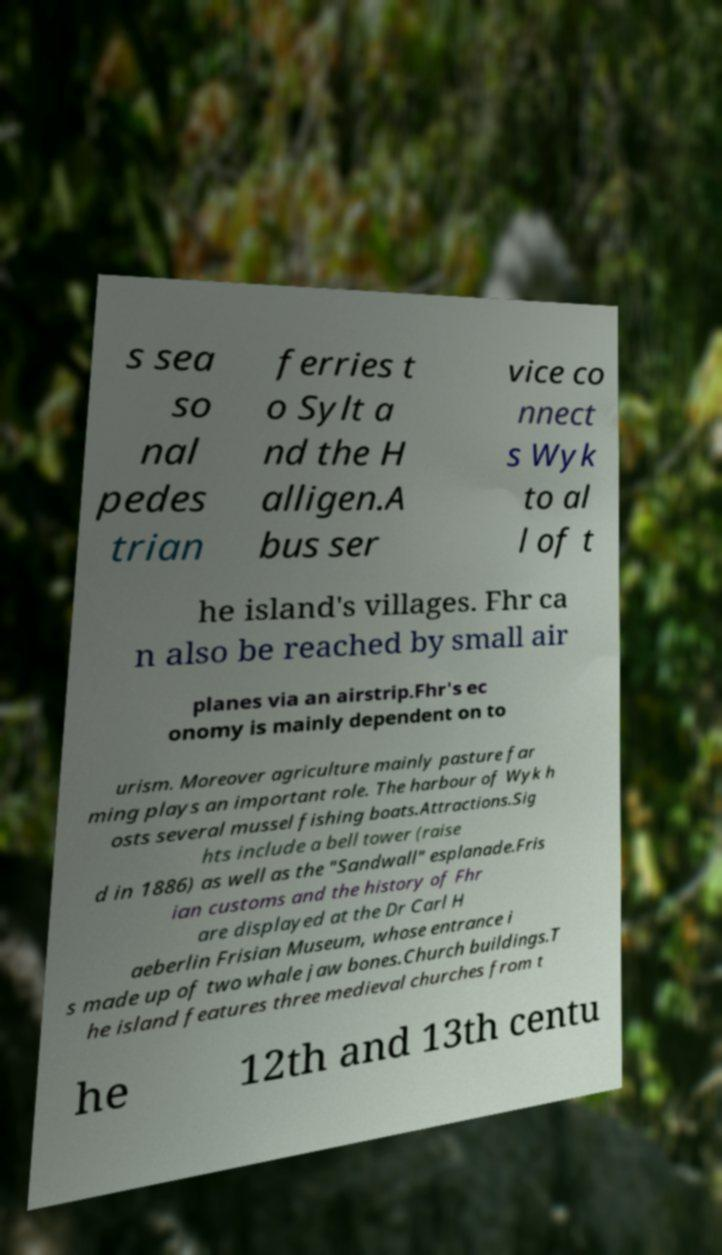Please read and relay the text visible in this image. What does it say? s sea so nal pedes trian ferries t o Sylt a nd the H alligen.A bus ser vice co nnect s Wyk to al l of t he island's villages. Fhr ca n also be reached by small air planes via an airstrip.Fhr's ec onomy is mainly dependent on to urism. Moreover agriculture mainly pasture far ming plays an important role. The harbour of Wyk h osts several mussel fishing boats.Attractions.Sig hts include a bell tower (raise d in 1886) as well as the "Sandwall" esplanade.Fris ian customs and the history of Fhr are displayed at the Dr Carl H aeberlin Frisian Museum, whose entrance i s made up of two whale jaw bones.Church buildings.T he island features three medieval churches from t he 12th and 13th centu 